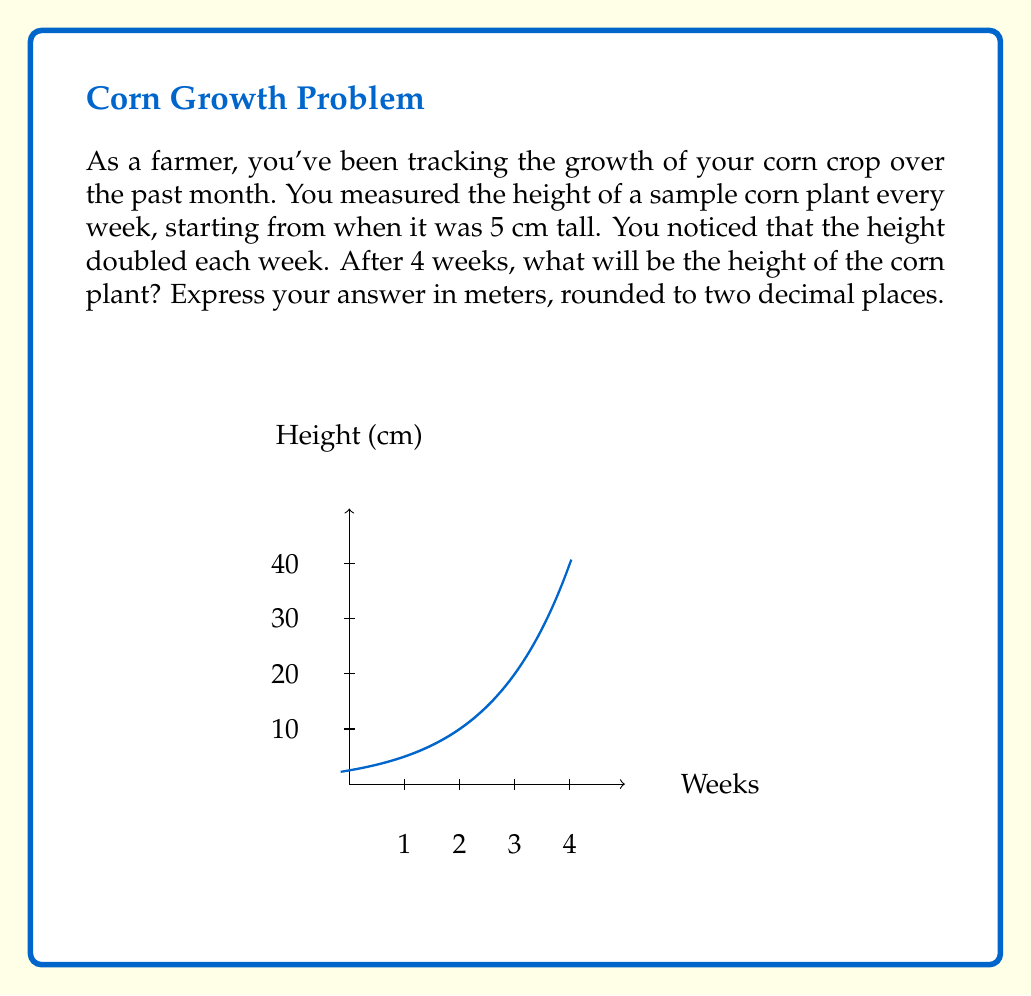Can you solve this math problem? Let's approach this step-by-step:

1) We start with an initial height of 5 cm.

2) The height doubles each week, which means we can use an exponential function with base 2.

3) The general form of our function will be:

   $$H(t) = 5 \cdot 2^t$$

   where $H(t)$ is the height in cm after $t$ weeks.

4) We want to know the height after 4 weeks, so we'll calculate $H(4)$:

   $$H(4) = 5 \cdot 2^4 = 5 \cdot 16 = 80$$

5) So after 4 weeks, the corn plant will be 80 cm tall.

6) The question asks for the answer in meters. To convert from cm to m, we divide by 100:

   $$80 \text{ cm} = 80 \div 100 = 0.80 \text{ m}$$

7) Rounding to two decimal places doesn't change this value.

Therefore, after 4 weeks, the corn plant will be 0.80 meters tall.
Answer: 0.80 m 